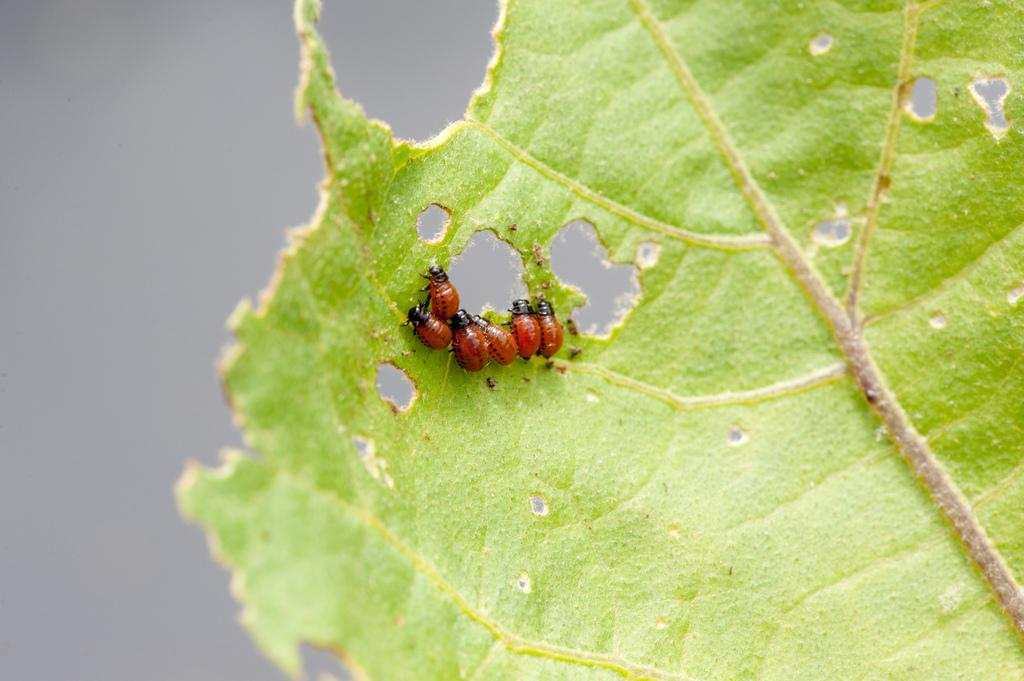What is present on the leaf in the image? There is an insect on the leaf in the image. What is the main subject of the image? The main subject of the image is a leaf with an insect on it. How would you describe the background of the image? The background of the image is blurred. What type of wool is being spun by the ghost in the image? There is no ghost or wool present in the image; it features a leaf with an insect on it. 